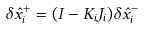Convert formula to latex. <formula><loc_0><loc_0><loc_500><loc_500>\delta \hat { x } _ { i } ^ { + } = ( { I } - { K } _ { i } { J } _ { i } ) \delta \hat { x } _ { i } ^ { - }</formula> 